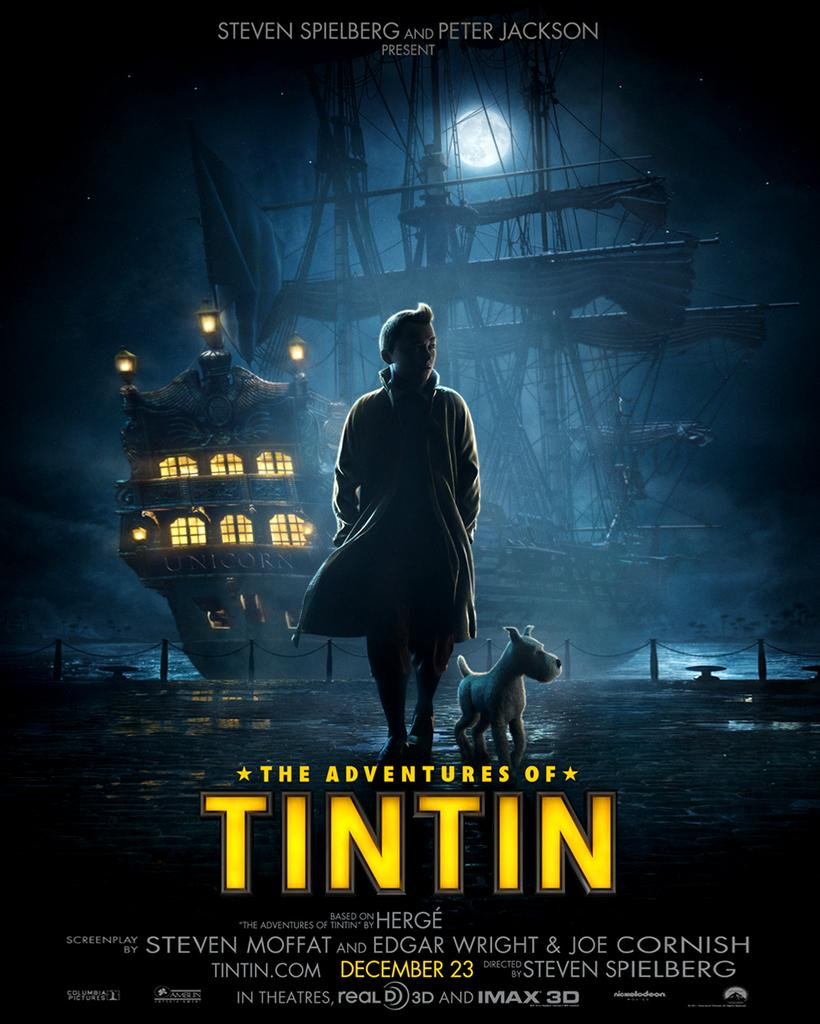<image>
Give a short and clear explanation of the subsequent image. poster for the adventures of tintin coming out on december 23 